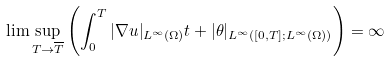Convert formula to latex. <formula><loc_0><loc_0><loc_500><loc_500>\lim \sup _ { T \rightarrow \overline { T } } \left ( \int _ { 0 } ^ { T } | \nabla u | _ { L ^ { \infty } ( \Omega ) } t + | \theta | _ { L ^ { \infty } ( [ 0 , T ] ; L ^ { \infty } ( \Omega ) ) } \right ) = \infty</formula> 